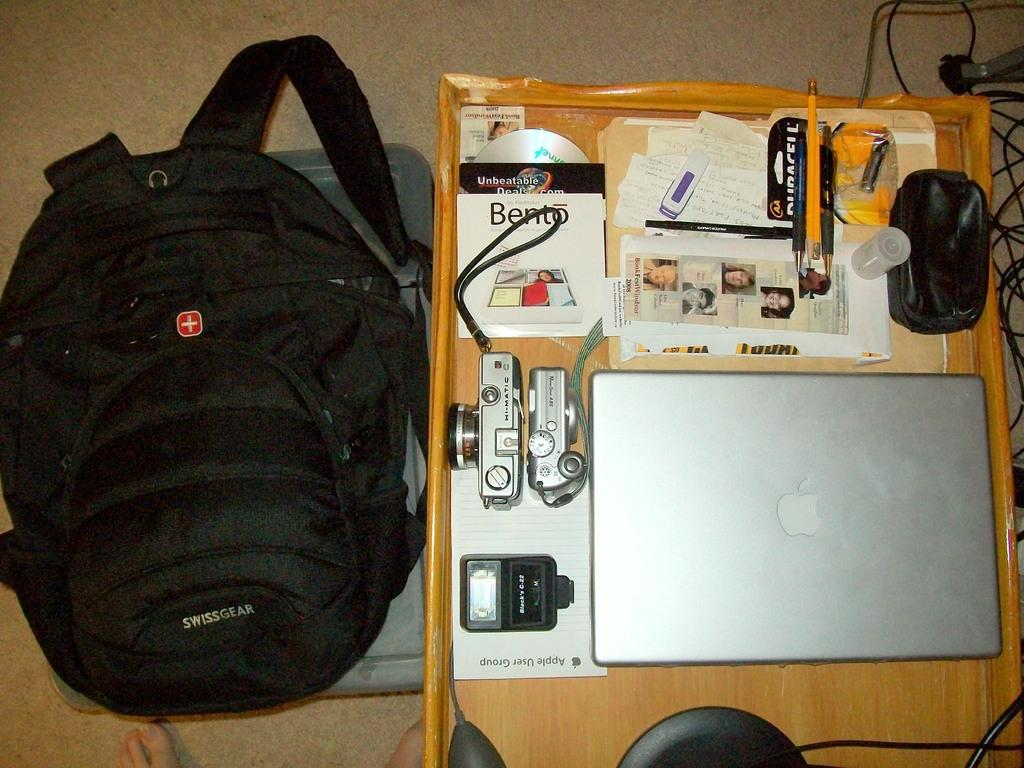What electronic device is on the table in the image? There is a laptop on the table in the image. What other electronic devices can be seen on the table? There are two cameras on the table. What else is on the table besides the electronic devices? There are other articles on the table. What is located beside the table in the image? There is a backpack beside the table. What time of day is the laptop being used for recess in the image? The image does not provide any information about the time of day or the purpose of using the laptop, and there is no mention of recess in the image. 